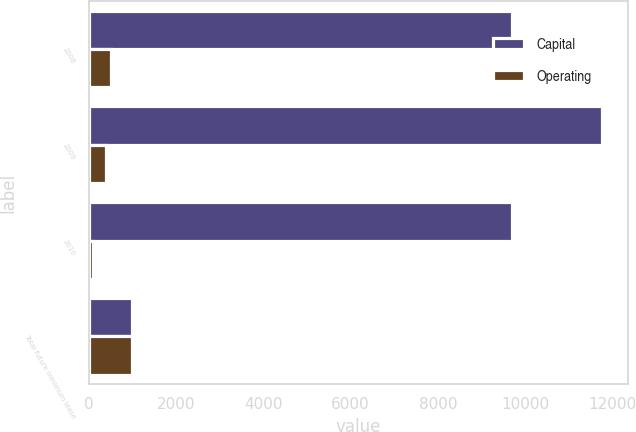Convert chart to OTSL. <chart><loc_0><loc_0><loc_500><loc_500><stacked_bar_chart><ecel><fcel>2008<fcel>2009<fcel>2010<fcel>Total future minimum lease<nl><fcel>Capital<fcel>9697<fcel>11774<fcel>9691<fcel>985<nl><fcel>Operating<fcel>508<fcel>378<fcel>99<fcel>985<nl></chart> 